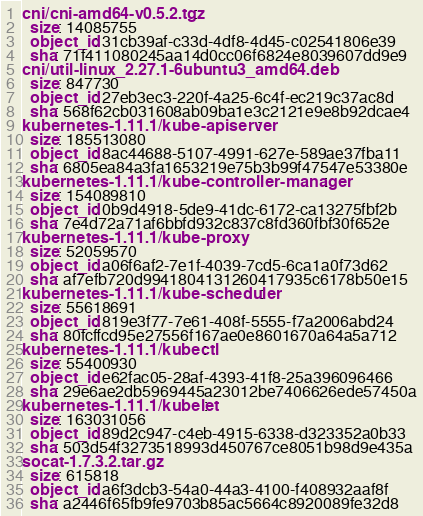<code> <loc_0><loc_0><loc_500><loc_500><_YAML_>cni/cni-amd64-v0.5.2.tgz:
  size: 14085755
  object_id: 31cb39af-c33d-4df8-4d45-c02541806e39
  sha: 71f411080245aa14d0cc06f6824e8039607dd9e9
cni/util-linux_2.27.1-6ubuntu3_amd64.deb:
  size: 847730
  object_id: 27eb3ec3-220f-4a25-6c4f-ec219c37ac8d
  sha: 568f62cb031608ab09ba1e3c2121e9e8b92dcae4
kubernetes-1.11.1/kube-apiserver:
  size: 185513080
  object_id: 8ac44688-5107-4991-627e-589ae37fba11
  sha: 6805ea84a3fa1653219e75b3b99f47547e53380e
kubernetes-1.11.1/kube-controller-manager:
  size: 154089810
  object_id: 0b9d4918-5de9-41dc-6172-ca13275fbf2b
  sha: 7e4d72a71af6bbfd932c837c8fd360fbf30f652e
kubernetes-1.11.1/kube-proxy:
  size: 52059570
  object_id: a06f6af2-7e1f-4039-7cd5-6ca1a0f73d62
  sha: af7efb720d9941804131260417935c6178b50e15
kubernetes-1.11.1/kube-scheduler:
  size: 55618691
  object_id: 819e3f77-7e61-408f-5555-f7a2006abd24
  sha: 80fcffcd95e27556f167ae0e8601670a64a5a712
kubernetes-1.11.1/kubectl:
  size: 55400930
  object_id: e62fac05-28af-4393-41f8-25a396096466
  sha: 29e6ae2db5969445a23012be7406626ede57450a
kubernetes-1.11.1/kubelet:
  size: 163031056
  object_id: 89d2c947-c4eb-4915-6338-d323352a0b33
  sha: 503d54f3273518993d450767ce8051b98d9e435a
socat-1.7.3.2.tar.gz:
  size: 615818
  object_id: a6f3dcb3-54a0-44a3-4100-f408932aaf8f
  sha: a2446f65fb9fe9703b85ac5664c8920089fe32d8
</code> 